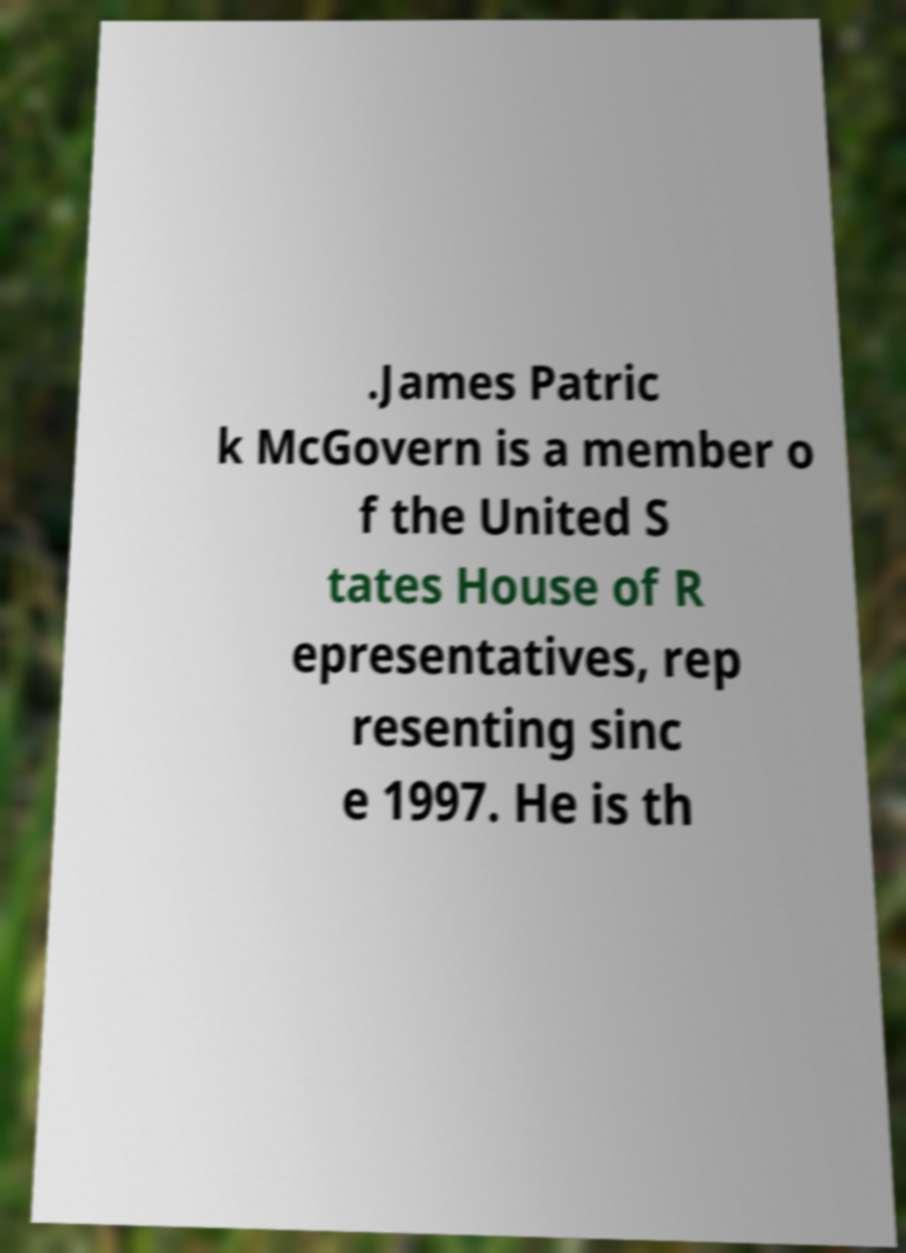Could you extract and type out the text from this image? .James Patric k McGovern is a member o f the United S tates House of R epresentatives, rep resenting sinc e 1997. He is th 